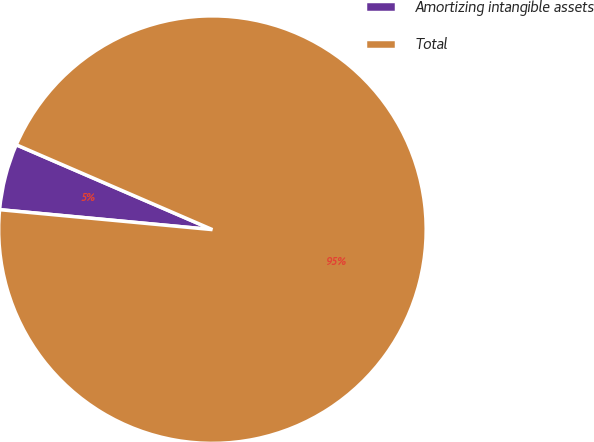<chart> <loc_0><loc_0><loc_500><loc_500><pie_chart><fcel>Amortizing intangible assets<fcel>Total<nl><fcel>5.01%<fcel>94.99%<nl></chart> 